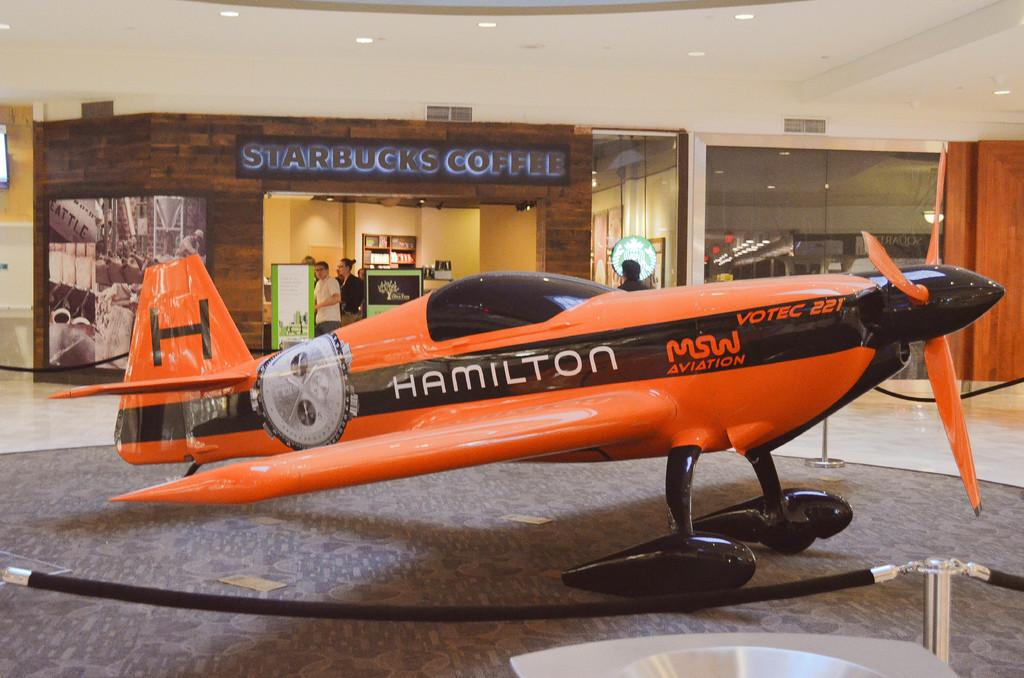What is the main subject of the image? The main subject of the image is an airplane on the ground. What can be seen in the foreground of the image? There is a fence in the image. What is visible in the background of the image? Banners and lights are visible in the background, along with people standing. What type of protest is taking place near the airplane in the image? There is no protest present in the image; it only features an airplane on the ground, a fence, banners, lights, and people standing in the background. 